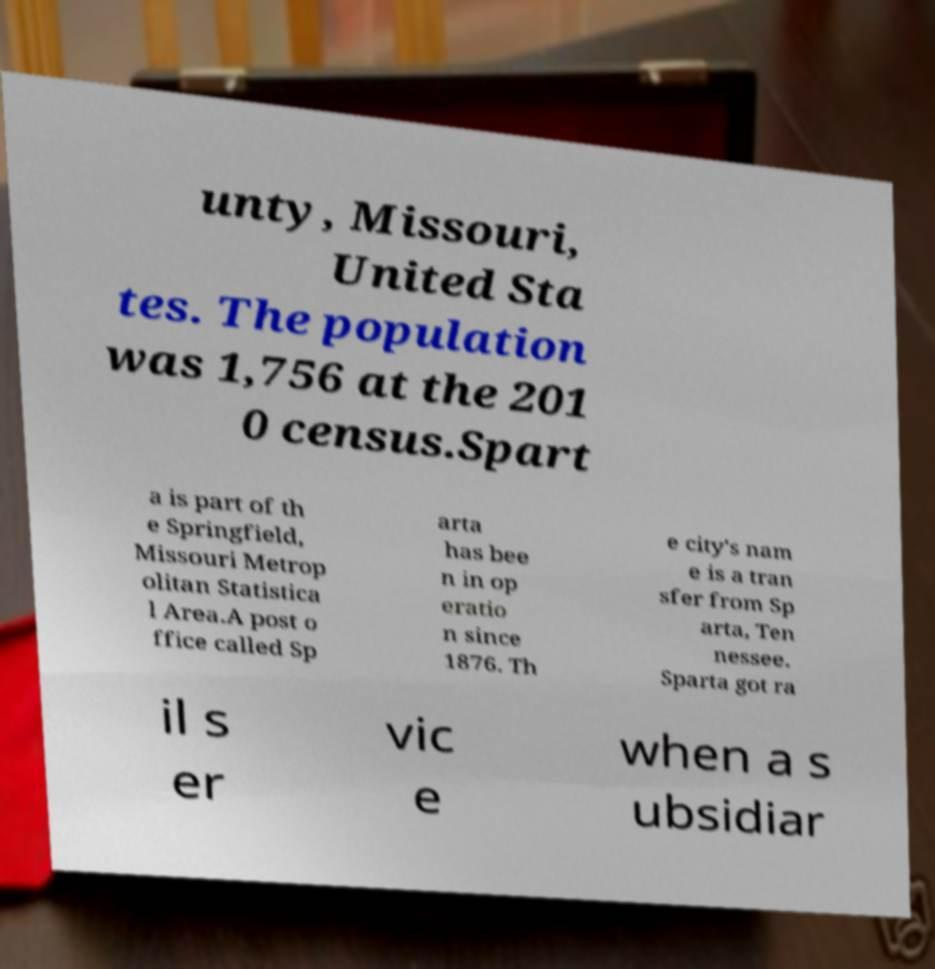Could you extract and type out the text from this image? unty, Missouri, United Sta tes. The population was 1,756 at the 201 0 census.Spart a is part of th e Springfield, Missouri Metrop olitan Statistica l Area.A post o ffice called Sp arta has bee n in op eratio n since 1876. Th e city's nam e is a tran sfer from Sp arta, Ten nessee. Sparta got ra il s er vic e when a s ubsidiar 